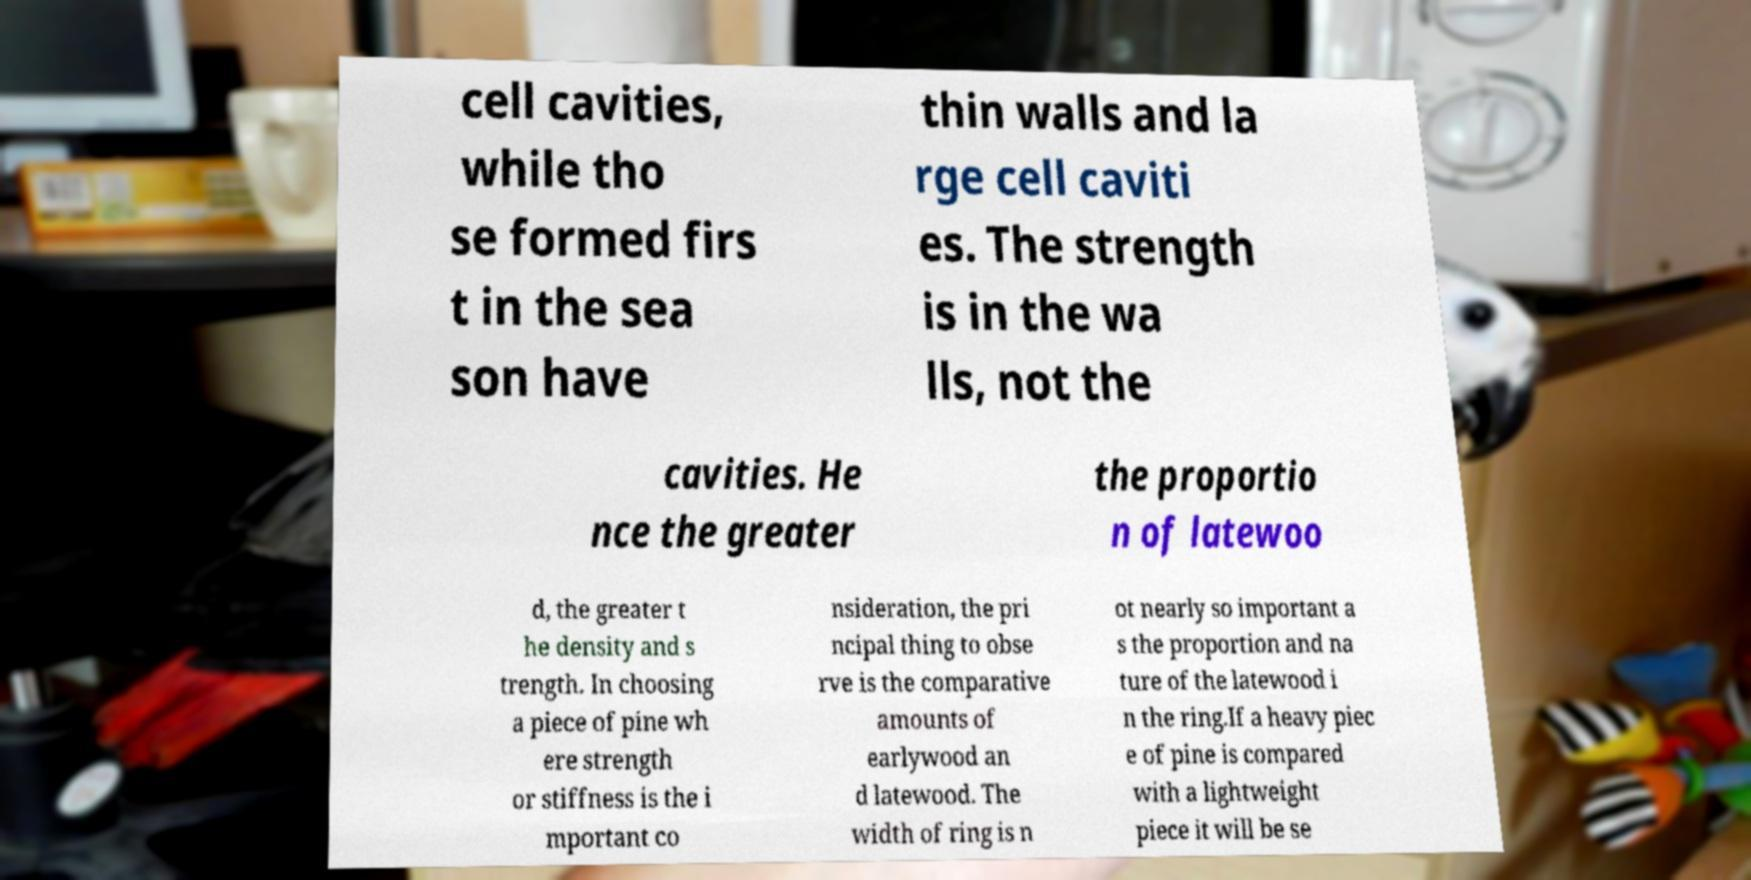Could you assist in decoding the text presented in this image and type it out clearly? cell cavities, while tho se formed firs t in the sea son have thin walls and la rge cell caviti es. The strength is in the wa lls, not the cavities. He nce the greater the proportio n of latewoo d, the greater t he density and s trength. In choosing a piece of pine wh ere strength or stiffness is the i mportant co nsideration, the pri ncipal thing to obse rve is the comparative amounts of earlywood an d latewood. The width of ring is n ot nearly so important a s the proportion and na ture of the latewood i n the ring.If a heavy piec e of pine is compared with a lightweight piece it will be se 